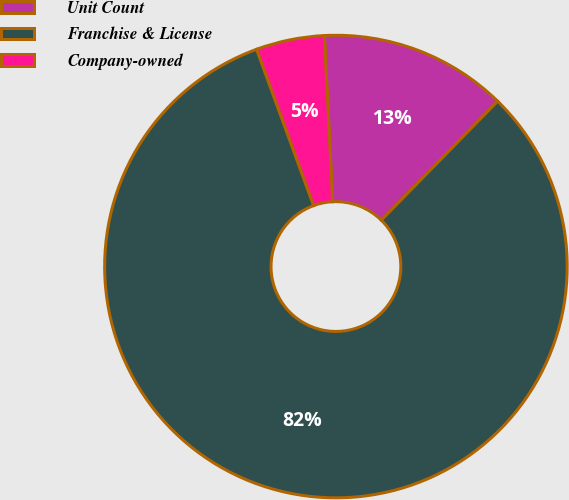<chart> <loc_0><loc_0><loc_500><loc_500><pie_chart><fcel>Unit Count<fcel>Franchise & License<fcel>Company-owned<nl><fcel>13.12%<fcel>82.11%<fcel>4.77%<nl></chart> 